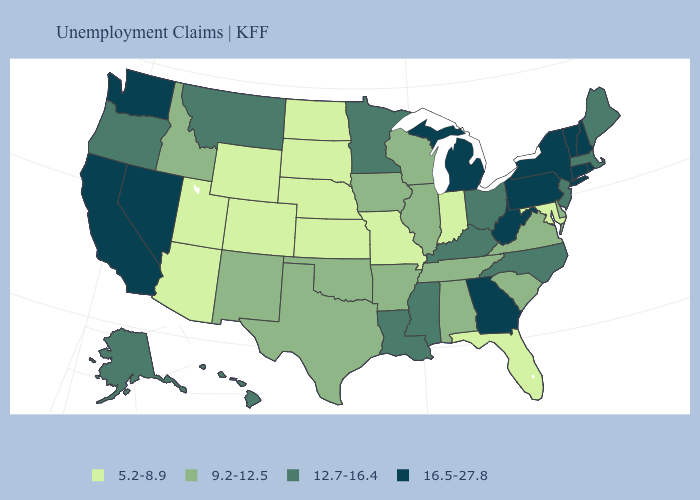Does Virginia have a lower value than Texas?
Be succinct. No. How many symbols are there in the legend?
Write a very short answer. 4. Among the states that border Iowa , which have the highest value?
Quick response, please. Minnesota. What is the value of Rhode Island?
Write a very short answer. 16.5-27.8. What is the highest value in states that border Mississippi?
Concise answer only. 12.7-16.4. What is the highest value in the USA?
Answer briefly. 16.5-27.8. What is the value of Hawaii?
Keep it brief. 12.7-16.4. Among the states that border Oregon , does Idaho have the highest value?
Answer briefly. No. What is the value of Mississippi?
Keep it brief. 12.7-16.4. Does Wisconsin have a lower value than Tennessee?
Quick response, please. No. Name the states that have a value in the range 12.7-16.4?
Give a very brief answer. Alaska, Hawaii, Kentucky, Louisiana, Maine, Massachusetts, Minnesota, Mississippi, Montana, New Jersey, North Carolina, Ohio, Oregon. Name the states that have a value in the range 5.2-8.9?
Short answer required. Arizona, Colorado, Florida, Indiana, Kansas, Maryland, Missouri, Nebraska, North Dakota, South Dakota, Utah, Wyoming. Name the states that have a value in the range 5.2-8.9?
Be succinct. Arizona, Colorado, Florida, Indiana, Kansas, Maryland, Missouri, Nebraska, North Dakota, South Dakota, Utah, Wyoming. Does Montana have the lowest value in the West?
Be succinct. No. Name the states that have a value in the range 12.7-16.4?
Keep it brief. Alaska, Hawaii, Kentucky, Louisiana, Maine, Massachusetts, Minnesota, Mississippi, Montana, New Jersey, North Carolina, Ohio, Oregon. 